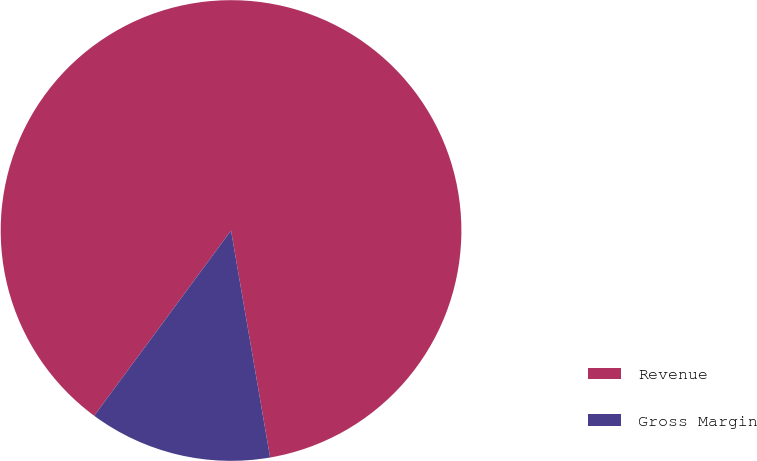Convert chart. <chart><loc_0><loc_0><loc_500><loc_500><pie_chart><fcel>Revenue<fcel>Gross Margin<nl><fcel>87.16%<fcel>12.84%<nl></chart> 